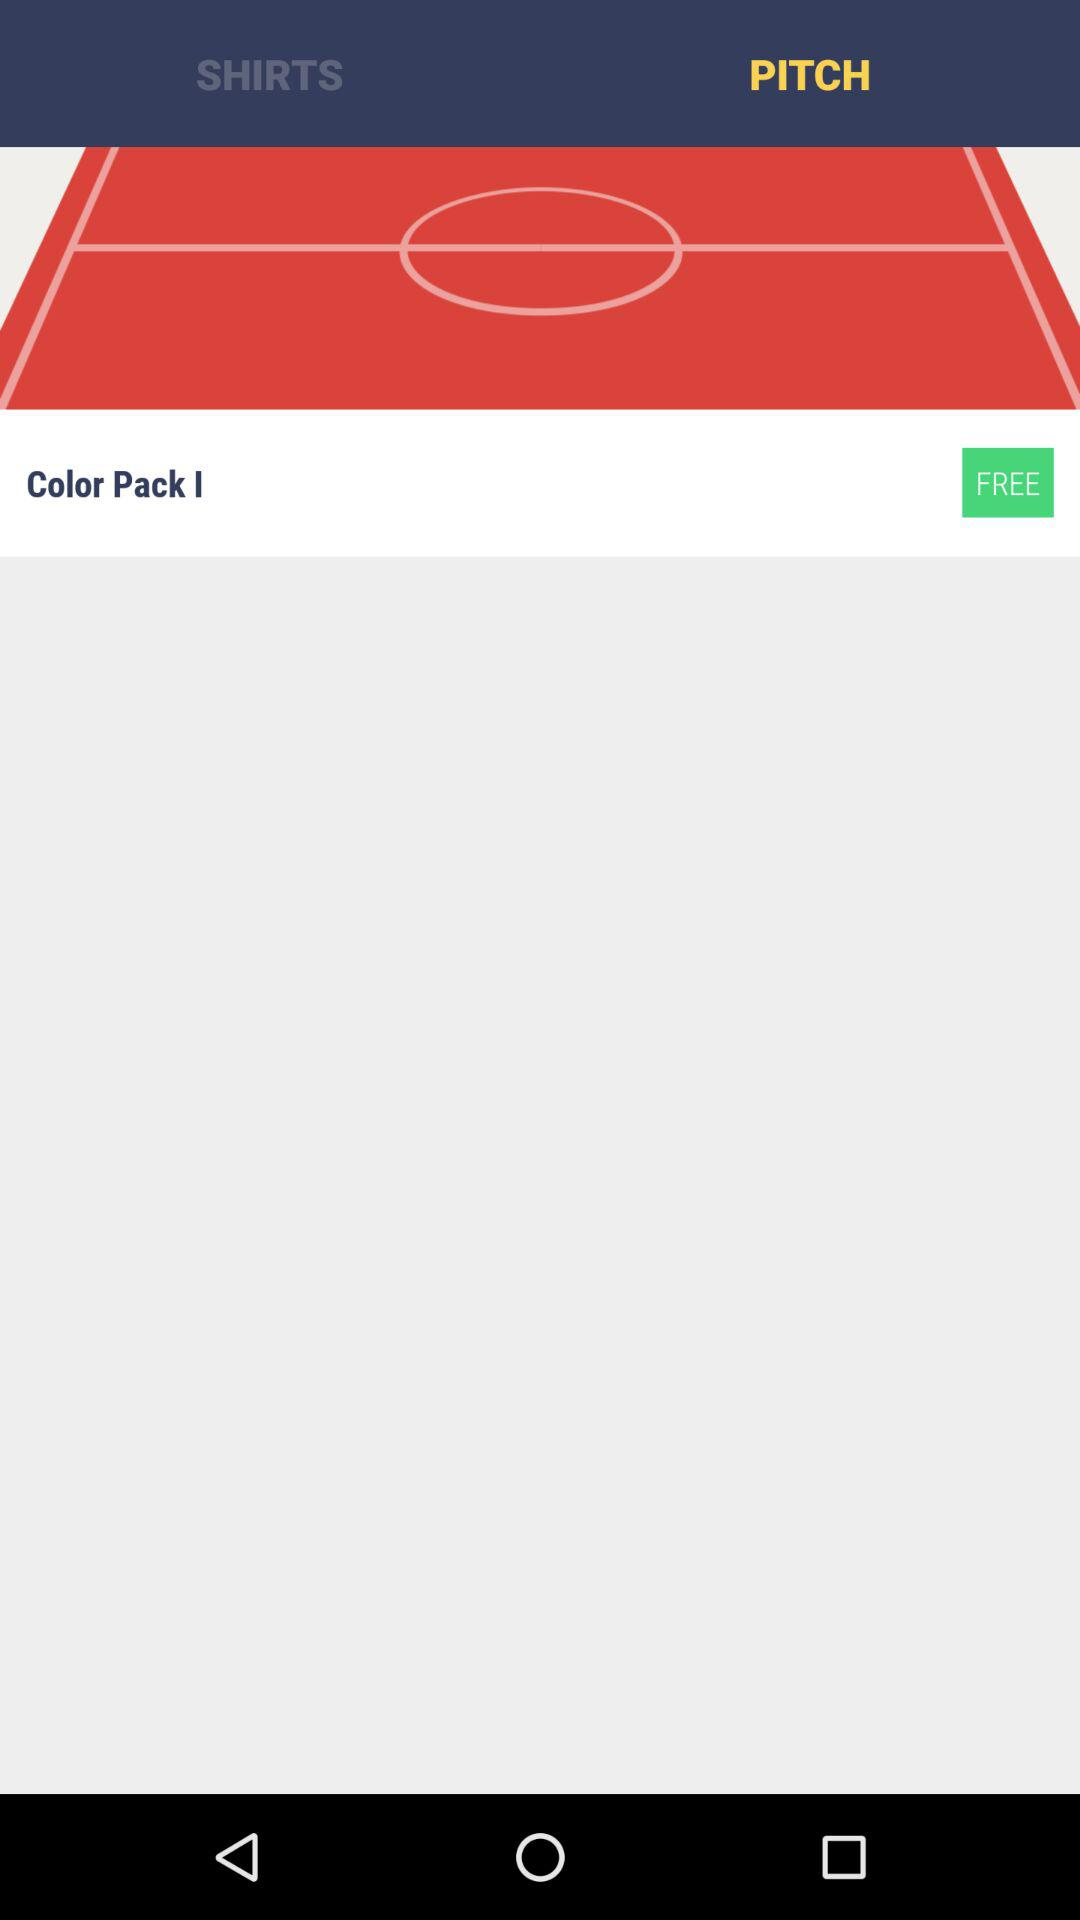What's the price of "Color Pack I"? "Color Pack I" is free. 